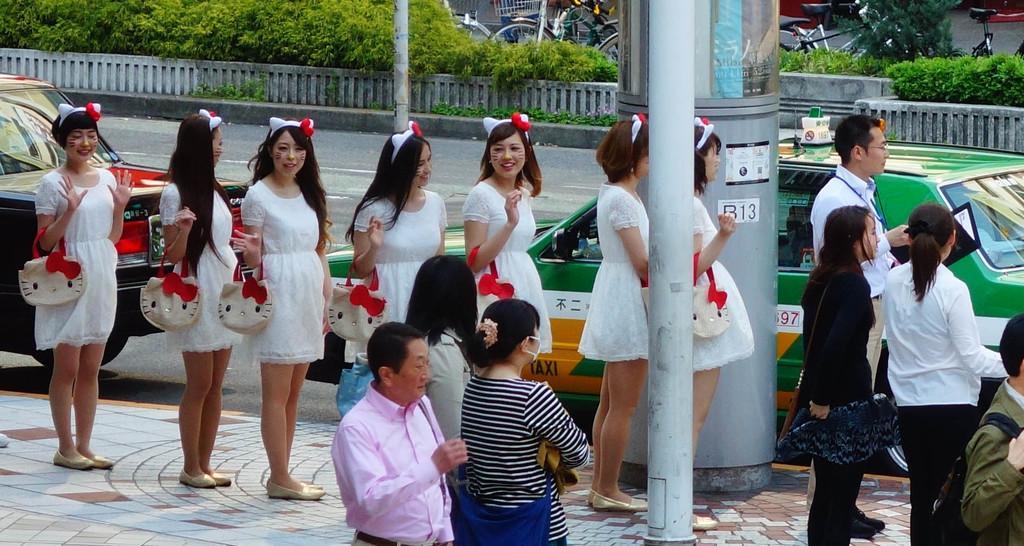How would you summarize this image in a sentence or two? In this picture I can observe some women standing in the line. They are wearing white color dresses. On the right side I can observe a pole. There are two cars parked on the road. In the background I can observe some plants and bicycles. 